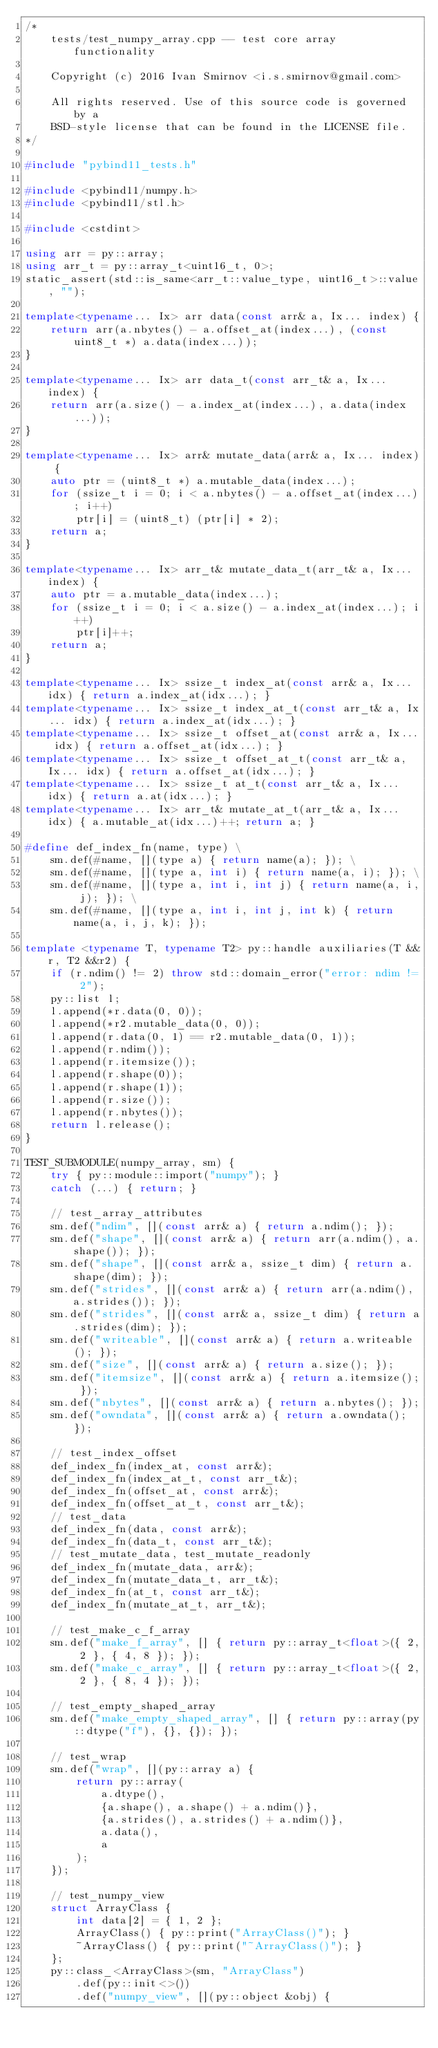<code> <loc_0><loc_0><loc_500><loc_500><_C++_>/*
    tests/test_numpy_array.cpp -- test core array functionality

    Copyright (c) 2016 Ivan Smirnov <i.s.smirnov@gmail.com>

    All rights reserved. Use of this source code is governed by a
    BSD-style license that can be found in the LICENSE file.
*/

#include "pybind11_tests.h"

#include <pybind11/numpy.h>
#include <pybind11/stl.h>

#include <cstdint>

using arr = py::array;
using arr_t = py::array_t<uint16_t, 0>;
static_assert(std::is_same<arr_t::value_type, uint16_t>::value, "");

template<typename... Ix> arr data(const arr& a, Ix... index) {
    return arr(a.nbytes() - a.offset_at(index...), (const uint8_t *) a.data(index...));
}

template<typename... Ix> arr data_t(const arr_t& a, Ix... index) {
    return arr(a.size() - a.index_at(index...), a.data(index...));
}

template<typename... Ix> arr& mutate_data(arr& a, Ix... index) {
    auto ptr = (uint8_t *) a.mutable_data(index...);
    for (ssize_t i = 0; i < a.nbytes() - a.offset_at(index...); i++)
        ptr[i] = (uint8_t) (ptr[i] * 2);
    return a;
}

template<typename... Ix> arr_t& mutate_data_t(arr_t& a, Ix... index) {
    auto ptr = a.mutable_data(index...);
    for (ssize_t i = 0; i < a.size() - a.index_at(index...); i++)
        ptr[i]++;
    return a;
}

template<typename... Ix> ssize_t index_at(const arr& a, Ix... idx) { return a.index_at(idx...); }
template<typename... Ix> ssize_t index_at_t(const arr_t& a, Ix... idx) { return a.index_at(idx...); }
template<typename... Ix> ssize_t offset_at(const arr& a, Ix... idx) { return a.offset_at(idx...); }
template<typename... Ix> ssize_t offset_at_t(const arr_t& a, Ix... idx) { return a.offset_at(idx...); }
template<typename... Ix> ssize_t at_t(const arr_t& a, Ix... idx) { return a.at(idx...); }
template<typename... Ix> arr_t& mutate_at_t(arr_t& a, Ix... idx) { a.mutable_at(idx...)++; return a; }

#define def_index_fn(name, type) \
    sm.def(#name, [](type a) { return name(a); }); \
    sm.def(#name, [](type a, int i) { return name(a, i); }); \
    sm.def(#name, [](type a, int i, int j) { return name(a, i, j); }); \
    sm.def(#name, [](type a, int i, int j, int k) { return name(a, i, j, k); });

template <typename T, typename T2> py::handle auxiliaries(T &&r, T2 &&r2) {
    if (r.ndim() != 2) throw std::domain_error("error: ndim != 2");
    py::list l;
    l.append(*r.data(0, 0));
    l.append(*r2.mutable_data(0, 0));
    l.append(r.data(0, 1) == r2.mutable_data(0, 1));
    l.append(r.ndim());
    l.append(r.itemsize());
    l.append(r.shape(0));
    l.append(r.shape(1));
    l.append(r.size());
    l.append(r.nbytes());
    return l.release();
}

TEST_SUBMODULE(numpy_array, sm) {
    try { py::module::import("numpy"); }
    catch (...) { return; }

    // test_array_attributes
    sm.def("ndim", [](const arr& a) { return a.ndim(); });
    sm.def("shape", [](const arr& a) { return arr(a.ndim(), a.shape()); });
    sm.def("shape", [](const arr& a, ssize_t dim) { return a.shape(dim); });
    sm.def("strides", [](const arr& a) { return arr(a.ndim(), a.strides()); });
    sm.def("strides", [](const arr& a, ssize_t dim) { return a.strides(dim); });
    sm.def("writeable", [](const arr& a) { return a.writeable(); });
    sm.def("size", [](const arr& a) { return a.size(); });
    sm.def("itemsize", [](const arr& a) { return a.itemsize(); });
    sm.def("nbytes", [](const arr& a) { return a.nbytes(); });
    sm.def("owndata", [](const arr& a) { return a.owndata(); });

    // test_index_offset
    def_index_fn(index_at, const arr&);
    def_index_fn(index_at_t, const arr_t&);
    def_index_fn(offset_at, const arr&);
    def_index_fn(offset_at_t, const arr_t&);
    // test_data
    def_index_fn(data, const arr&);
    def_index_fn(data_t, const arr_t&);
    // test_mutate_data, test_mutate_readonly
    def_index_fn(mutate_data, arr&);
    def_index_fn(mutate_data_t, arr_t&);
    def_index_fn(at_t, const arr_t&);
    def_index_fn(mutate_at_t, arr_t&);

    // test_make_c_f_array
    sm.def("make_f_array", [] { return py::array_t<float>({ 2, 2 }, { 4, 8 }); });
    sm.def("make_c_array", [] { return py::array_t<float>({ 2, 2 }, { 8, 4 }); });

    // test_empty_shaped_array
    sm.def("make_empty_shaped_array", [] { return py::array(py::dtype("f"), {}, {}); });

    // test_wrap
    sm.def("wrap", [](py::array a) {
        return py::array(
            a.dtype(),
            {a.shape(), a.shape() + a.ndim()},
            {a.strides(), a.strides() + a.ndim()},
            a.data(),
            a
        );
    });

    // test_numpy_view
    struct ArrayClass {
        int data[2] = { 1, 2 };
        ArrayClass() { py::print("ArrayClass()"); }
        ~ArrayClass() { py::print("~ArrayClass()"); }
    };
    py::class_<ArrayClass>(sm, "ArrayClass")
        .def(py::init<>())
        .def("numpy_view", [](py::object &obj) {</code> 